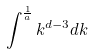Convert formula to latex. <formula><loc_0><loc_0><loc_500><loc_500>\int ^ { \frac { 1 } { a } } k ^ { d - 3 } d k</formula> 